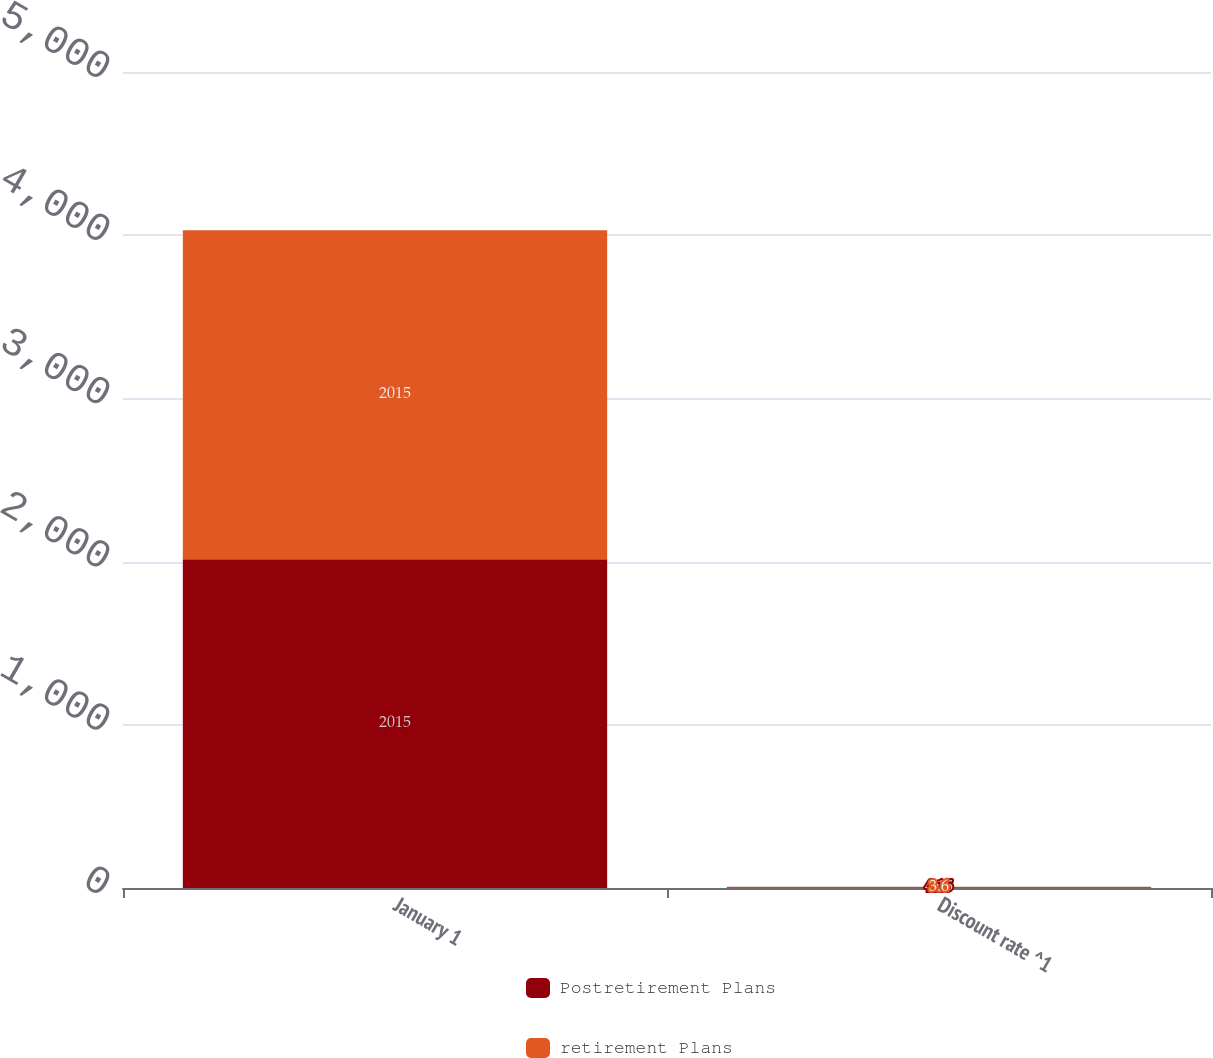Convert chart to OTSL. <chart><loc_0><loc_0><loc_500><loc_500><stacked_bar_chart><ecel><fcel>January 1<fcel>Discount rate ^1<nl><fcel>Postretirement Plans<fcel>2015<fcel>4.15<nl><fcel>retirement Plans<fcel>2015<fcel>3.6<nl></chart> 